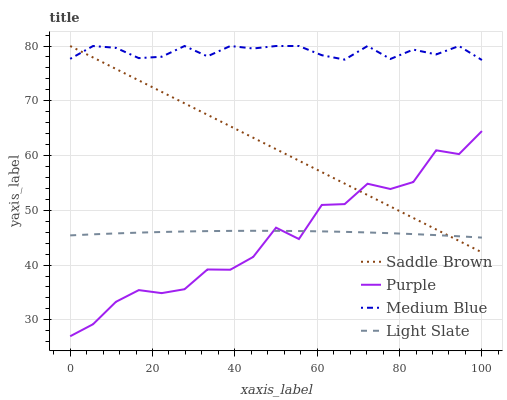Does Light Slate have the minimum area under the curve?
Answer yes or no. No. Does Light Slate have the maximum area under the curve?
Answer yes or no. No. Is Light Slate the smoothest?
Answer yes or no. No. Is Light Slate the roughest?
Answer yes or no. No. Does Light Slate have the lowest value?
Answer yes or no. No. Does Light Slate have the highest value?
Answer yes or no. No. Is Purple less than Medium Blue?
Answer yes or no. Yes. Is Medium Blue greater than Light Slate?
Answer yes or no. Yes. Does Purple intersect Medium Blue?
Answer yes or no. No. 